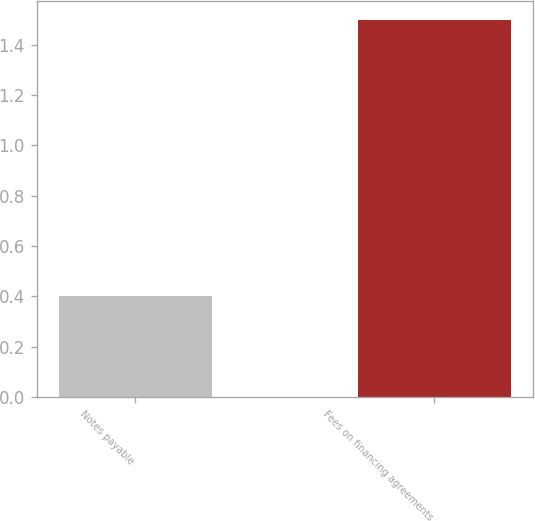Convert chart. <chart><loc_0><loc_0><loc_500><loc_500><bar_chart><fcel>Notes payable<fcel>Fees on financing agreements<nl><fcel>0.4<fcel>1.5<nl></chart> 